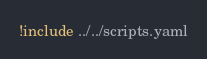Convert code to text. <code><loc_0><loc_0><loc_500><loc_500><_YAML_>!include ../../scripts.yaml</code> 